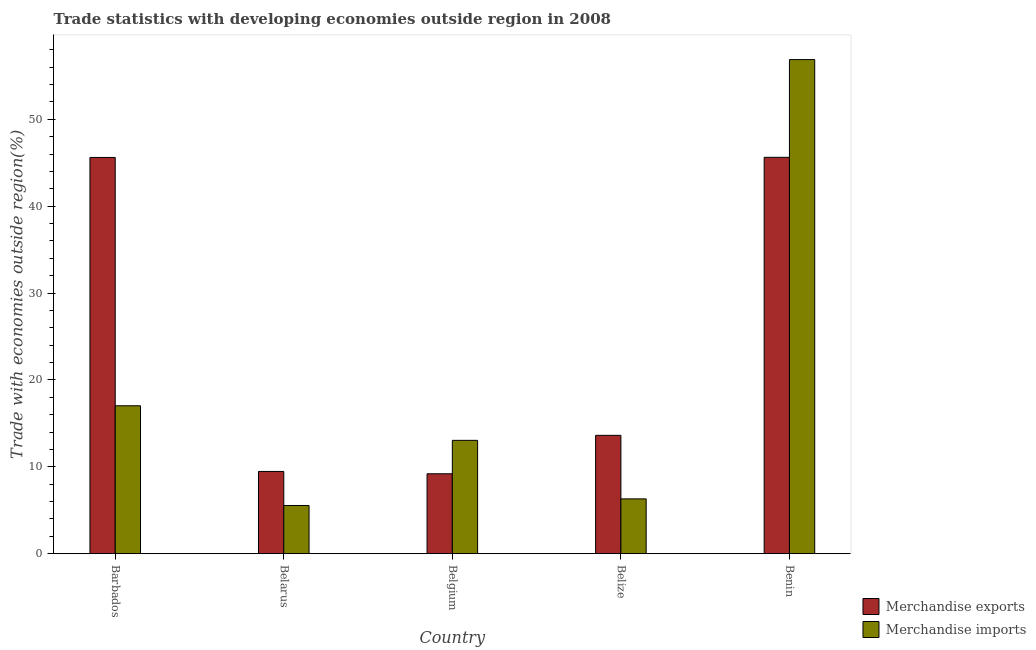How many groups of bars are there?
Provide a succinct answer. 5. Are the number of bars per tick equal to the number of legend labels?
Make the answer very short. Yes. Are the number of bars on each tick of the X-axis equal?
Make the answer very short. Yes. How many bars are there on the 3rd tick from the left?
Provide a short and direct response. 2. What is the label of the 4th group of bars from the left?
Your response must be concise. Belize. In how many cases, is the number of bars for a given country not equal to the number of legend labels?
Your answer should be very brief. 0. What is the merchandise exports in Belize?
Give a very brief answer. 13.62. Across all countries, what is the maximum merchandise imports?
Provide a succinct answer. 56.87. Across all countries, what is the minimum merchandise imports?
Give a very brief answer. 5.54. In which country was the merchandise imports maximum?
Keep it short and to the point. Benin. In which country was the merchandise exports minimum?
Provide a short and direct response. Belgium. What is the total merchandise exports in the graph?
Ensure brevity in your answer.  123.5. What is the difference between the merchandise exports in Belgium and that in Benin?
Your answer should be very brief. -36.43. What is the difference between the merchandise imports in Belarus and the merchandise exports in Belgium?
Give a very brief answer. -3.65. What is the average merchandise exports per country?
Offer a terse response. 24.7. What is the difference between the merchandise imports and merchandise exports in Belarus?
Make the answer very short. -3.92. In how many countries, is the merchandise imports greater than 8 %?
Give a very brief answer. 3. What is the ratio of the merchandise exports in Barbados to that in Benin?
Your answer should be very brief. 1. Is the difference between the merchandise exports in Belarus and Belgium greater than the difference between the merchandise imports in Belarus and Belgium?
Offer a very short reply. Yes. What is the difference between the highest and the second highest merchandise imports?
Keep it short and to the point. 39.85. What is the difference between the highest and the lowest merchandise imports?
Offer a terse response. 51.33. In how many countries, is the merchandise imports greater than the average merchandise imports taken over all countries?
Your response must be concise. 1. Is the sum of the merchandise exports in Belarus and Belgium greater than the maximum merchandise imports across all countries?
Give a very brief answer. No. How many countries are there in the graph?
Offer a very short reply. 5. What is the difference between two consecutive major ticks on the Y-axis?
Your response must be concise. 10. Are the values on the major ticks of Y-axis written in scientific E-notation?
Make the answer very short. No. Does the graph contain any zero values?
Offer a terse response. No. How many legend labels are there?
Your answer should be very brief. 2. What is the title of the graph?
Your answer should be compact. Trade statistics with developing economies outside region in 2008. Does "Taxes on exports" appear as one of the legend labels in the graph?
Your answer should be compact. No. What is the label or title of the X-axis?
Your answer should be very brief. Country. What is the label or title of the Y-axis?
Provide a short and direct response. Trade with economies outside region(%). What is the Trade with economies outside region(%) of Merchandise exports in Barbados?
Offer a very short reply. 45.6. What is the Trade with economies outside region(%) in Merchandise imports in Barbados?
Offer a terse response. 17.02. What is the Trade with economies outside region(%) of Merchandise exports in Belarus?
Offer a very short reply. 9.46. What is the Trade with economies outside region(%) in Merchandise imports in Belarus?
Your answer should be very brief. 5.54. What is the Trade with economies outside region(%) of Merchandise exports in Belgium?
Offer a very short reply. 9.19. What is the Trade with economies outside region(%) in Merchandise imports in Belgium?
Your answer should be compact. 13.04. What is the Trade with economies outside region(%) in Merchandise exports in Belize?
Offer a very short reply. 13.62. What is the Trade with economies outside region(%) of Merchandise imports in Belize?
Offer a terse response. 6.3. What is the Trade with economies outside region(%) in Merchandise exports in Benin?
Offer a very short reply. 45.62. What is the Trade with economies outside region(%) in Merchandise imports in Benin?
Your answer should be very brief. 56.87. Across all countries, what is the maximum Trade with economies outside region(%) of Merchandise exports?
Provide a succinct answer. 45.62. Across all countries, what is the maximum Trade with economies outside region(%) in Merchandise imports?
Your response must be concise. 56.87. Across all countries, what is the minimum Trade with economies outside region(%) of Merchandise exports?
Give a very brief answer. 9.19. Across all countries, what is the minimum Trade with economies outside region(%) in Merchandise imports?
Keep it short and to the point. 5.54. What is the total Trade with economies outside region(%) of Merchandise exports in the graph?
Give a very brief answer. 123.5. What is the total Trade with economies outside region(%) in Merchandise imports in the graph?
Give a very brief answer. 98.78. What is the difference between the Trade with economies outside region(%) in Merchandise exports in Barbados and that in Belarus?
Provide a succinct answer. 36.14. What is the difference between the Trade with economies outside region(%) in Merchandise imports in Barbados and that in Belarus?
Your response must be concise. 11.48. What is the difference between the Trade with economies outside region(%) of Merchandise exports in Barbados and that in Belgium?
Your response must be concise. 36.41. What is the difference between the Trade with economies outside region(%) in Merchandise imports in Barbados and that in Belgium?
Your response must be concise. 3.98. What is the difference between the Trade with economies outside region(%) in Merchandise exports in Barbados and that in Belize?
Your response must be concise. 31.99. What is the difference between the Trade with economies outside region(%) in Merchandise imports in Barbados and that in Belize?
Your response must be concise. 10.72. What is the difference between the Trade with economies outside region(%) of Merchandise exports in Barbados and that in Benin?
Make the answer very short. -0.02. What is the difference between the Trade with economies outside region(%) in Merchandise imports in Barbados and that in Benin?
Your response must be concise. -39.85. What is the difference between the Trade with economies outside region(%) of Merchandise exports in Belarus and that in Belgium?
Your answer should be compact. 0.27. What is the difference between the Trade with economies outside region(%) in Merchandise imports in Belarus and that in Belgium?
Offer a very short reply. -7.5. What is the difference between the Trade with economies outside region(%) in Merchandise exports in Belarus and that in Belize?
Your answer should be very brief. -4.16. What is the difference between the Trade with economies outside region(%) in Merchandise imports in Belarus and that in Belize?
Provide a succinct answer. -0.76. What is the difference between the Trade with economies outside region(%) of Merchandise exports in Belarus and that in Benin?
Provide a succinct answer. -36.16. What is the difference between the Trade with economies outside region(%) of Merchandise imports in Belarus and that in Benin?
Offer a very short reply. -51.33. What is the difference between the Trade with economies outside region(%) in Merchandise exports in Belgium and that in Belize?
Your response must be concise. -4.42. What is the difference between the Trade with economies outside region(%) in Merchandise imports in Belgium and that in Belize?
Your answer should be compact. 6.74. What is the difference between the Trade with economies outside region(%) of Merchandise exports in Belgium and that in Benin?
Offer a terse response. -36.43. What is the difference between the Trade with economies outside region(%) in Merchandise imports in Belgium and that in Benin?
Your answer should be very brief. -43.83. What is the difference between the Trade with economies outside region(%) in Merchandise exports in Belize and that in Benin?
Your response must be concise. -32. What is the difference between the Trade with economies outside region(%) of Merchandise imports in Belize and that in Benin?
Offer a terse response. -50.57. What is the difference between the Trade with economies outside region(%) of Merchandise exports in Barbados and the Trade with economies outside region(%) of Merchandise imports in Belarus?
Ensure brevity in your answer.  40.06. What is the difference between the Trade with economies outside region(%) in Merchandise exports in Barbados and the Trade with economies outside region(%) in Merchandise imports in Belgium?
Your response must be concise. 32.56. What is the difference between the Trade with economies outside region(%) of Merchandise exports in Barbados and the Trade with economies outside region(%) of Merchandise imports in Belize?
Provide a short and direct response. 39.3. What is the difference between the Trade with economies outside region(%) in Merchandise exports in Barbados and the Trade with economies outside region(%) in Merchandise imports in Benin?
Your answer should be compact. -11.27. What is the difference between the Trade with economies outside region(%) in Merchandise exports in Belarus and the Trade with economies outside region(%) in Merchandise imports in Belgium?
Your response must be concise. -3.58. What is the difference between the Trade with economies outside region(%) of Merchandise exports in Belarus and the Trade with economies outside region(%) of Merchandise imports in Belize?
Keep it short and to the point. 3.16. What is the difference between the Trade with economies outside region(%) in Merchandise exports in Belarus and the Trade with economies outside region(%) in Merchandise imports in Benin?
Your answer should be very brief. -47.41. What is the difference between the Trade with economies outside region(%) in Merchandise exports in Belgium and the Trade with economies outside region(%) in Merchandise imports in Belize?
Your response must be concise. 2.89. What is the difference between the Trade with economies outside region(%) of Merchandise exports in Belgium and the Trade with economies outside region(%) of Merchandise imports in Benin?
Offer a very short reply. -47.68. What is the difference between the Trade with economies outside region(%) of Merchandise exports in Belize and the Trade with economies outside region(%) of Merchandise imports in Benin?
Your answer should be compact. -43.25. What is the average Trade with economies outside region(%) in Merchandise exports per country?
Ensure brevity in your answer.  24.7. What is the average Trade with economies outside region(%) of Merchandise imports per country?
Provide a short and direct response. 19.76. What is the difference between the Trade with economies outside region(%) in Merchandise exports and Trade with economies outside region(%) in Merchandise imports in Barbados?
Your response must be concise. 28.58. What is the difference between the Trade with economies outside region(%) in Merchandise exports and Trade with economies outside region(%) in Merchandise imports in Belarus?
Your answer should be very brief. 3.92. What is the difference between the Trade with economies outside region(%) of Merchandise exports and Trade with economies outside region(%) of Merchandise imports in Belgium?
Keep it short and to the point. -3.85. What is the difference between the Trade with economies outside region(%) in Merchandise exports and Trade with economies outside region(%) in Merchandise imports in Belize?
Your answer should be very brief. 7.31. What is the difference between the Trade with economies outside region(%) of Merchandise exports and Trade with economies outside region(%) of Merchandise imports in Benin?
Make the answer very short. -11.25. What is the ratio of the Trade with economies outside region(%) of Merchandise exports in Barbados to that in Belarus?
Your answer should be very brief. 4.82. What is the ratio of the Trade with economies outside region(%) in Merchandise imports in Barbados to that in Belarus?
Provide a short and direct response. 3.07. What is the ratio of the Trade with economies outside region(%) of Merchandise exports in Barbados to that in Belgium?
Offer a terse response. 4.96. What is the ratio of the Trade with economies outside region(%) in Merchandise imports in Barbados to that in Belgium?
Your response must be concise. 1.31. What is the ratio of the Trade with economies outside region(%) of Merchandise exports in Barbados to that in Belize?
Offer a very short reply. 3.35. What is the ratio of the Trade with economies outside region(%) in Merchandise imports in Barbados to that in Belize?
Make the answer very short. 2.7. What is the ratio of the Trade with economies outside region(%) of Merchandise exports in Barbados to that in Benin?
Offer a terse response. 1. What is the ratio of the Trade with economies outside region(%) of Merchandise imports in Barbados to that in Benin?
Offer a terse response. 0.3. What is the ratio of the Trade with economies outside region(%) in Merchandise exports in Belarus to that in Belgium?
Offer a very short reply. 1.03. What is the ratio of the Trade with economies outside region(%) in Merchandise imports in Belarus to that in Belgium?
Make the answer very short. 0.42. What is the ratio of the Trade with economies outside region(%) of Merchandise exports in Belarus to that in Belize?
Ensure brevity in your answer.  0.69. What is the ratio of the Trade with economies outside region(%) in Merchandise imports in Belarus to that in Belize?
Make the answer very short. 0.88. What is the ratio of the Trade with economies outside region(%) of Merchandise exports in Belarus to that in Benin?
Your answer should be compact. 0.21. What is the ratio of the Trade with economies outside region(%) of Merchandise imports in Belarus to that in Benin?
Offer a very short reply. 0.1. What is the ratio of the Trade with economies outside region(%) in Merchandise exports in Belgium to that in Belize?
Make the answer very short. 0.68. What is the ratio of the Trade with economies outside region(%) in Merchandise imports in Belgium to that in Belize?
Offer a terse response. 2.07. What is the ratio of the Trade with economies outside region(%) of Merchandise exports in Belgium to that in Benin?
Keep it short and to the point. 0.2. What is the ratio of the Trade with economies outside region(%) of Merchandise imports in Belgium to that in Benin?
Keep it short and to the point. 0.23. What is the ratio of the Trade with economies outside region(%) of Merchandise exports in Belize to that in Benin?
Give a very brief answer. 0.3. What is the ratio of the Trade with economies outside region(%) in Merchandise imports in Belize to that in Benin?
Your answer should be very brief. 0.11. What is the difference between the highest and the second highest Trade with economies outside region(%) of Merchandise exports?
Ensure brevity in your answer.  0.02. What is the difference between the highest and the second highest Trade with economies outside region(%) in Merchandise imports?
Keep it short and to the point. 39.85. What is the difference between the highest and the lowest Trade with economies outside region(%) in Merchandise exports?
Your answer should be compact. 36.43. What is the difference between the highest and the lowest Trade with economies outside region(%) of Merchandise imports?
Keep it short and to the point. 51.33. 